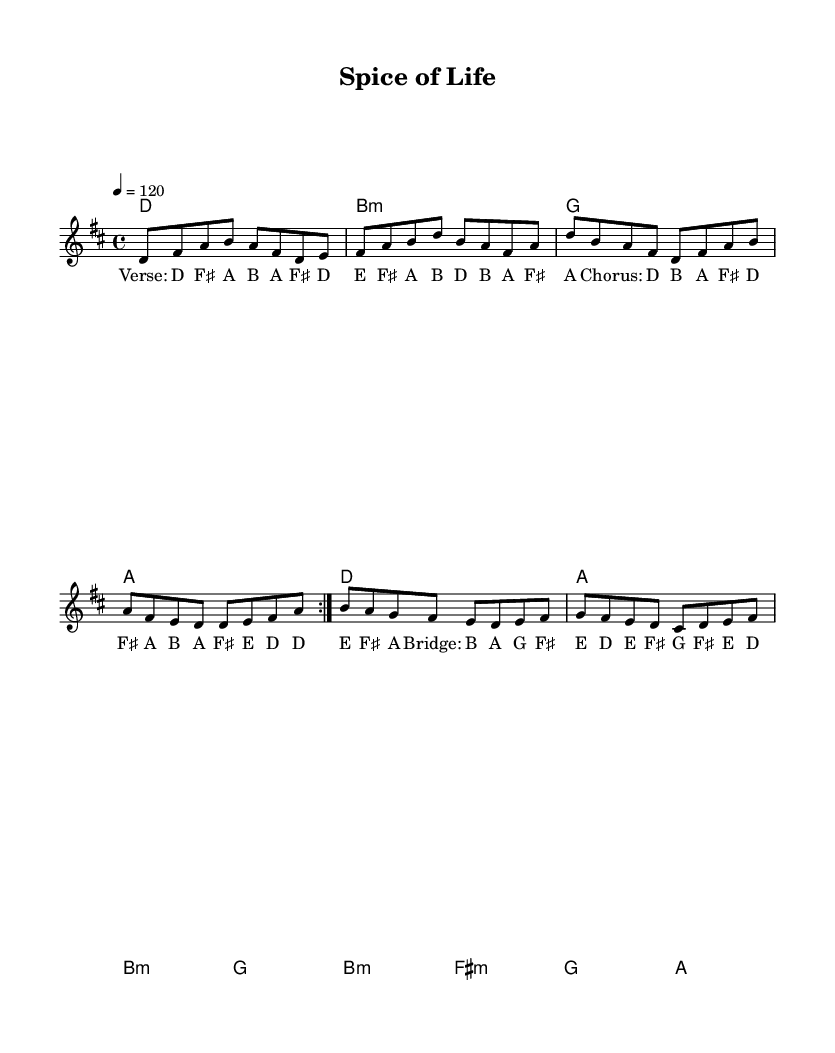What is the key signature of this music? The key signature indicates that the piece is in D major, which has two sharps: F sharp and C sharp. This can be identified at the beginning of the staff where the sharps are placed.
Answer: D major What is the time signature of this music? The time signature is found at the beginning of the score, where it shows 4/4. This means there are four beats in each measure and the quarter note gets one beat.
Answer: 4/4 What is the tempo marking of this music? The tempo marking is indicated with "4 = 120," which shows that there are 120 quarter note beats per minute. This is generally fast-paced, suitable for upbeat music.
Answer: 120 How many measures are in the melody? The melody contains a total of 8 measures, as indicated by the layout. Counting the measures from the beginning of the melody part to the end confirms this total.
Answer: 8 What is the tonic chord of the piece? The tonic chord is the first chord of the piece, which in this case is D major, as shown in the chord section. It establishes the home key of the composition.
Answer: D What is the structure pattern of the song? The song follows a structure of verses and a chorus, with a bridge section as well. The lyrics denote this layout, indicating repetition in verses and distinct sections for the chorus and bridge.
Answer: Verse-Chorus-Bridge How many different chords are used in the composition? The composition uses five different chords: D, B minor, G, A, and F sharp minor. These can be identified by looking at the chord progression indicated in the sheet music.
Answer: Five 